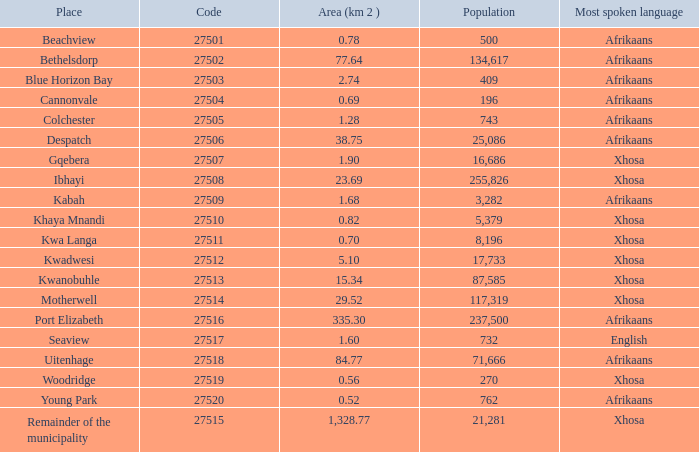I'm looking to parse the entire table for insights. Could you assist me with that? {'header': ['Place', 'Code', 'Area (km 2 )', 'Population', 'Most spoken language'], 'rows': [['Beachview', '27501', '0.78', '500', 'Afrikaans'], ['Bethelsdorp', '27502', '77.64', '134,617', 'Afrikaans'], ['Blue Horizon Bay', '27503', '2.74', '409', 'Afrikaans'], ['Cannonvale', '27504', '0.69', '196', 'Afrikaans'], ['Colchester', '27505', '1.28', '743', 'Afrikaans'], ['Despatch', '27506', '38.75', '25,086', 'Afrikaans'], ['Gqebera', '27507', '1.90', '16,686', 'Xhosa'], ['Ibhayi', '27508', '23.69', '255,826', 'Xhosa'], ['Kabah', '27509', '1.68', '3,282', 'Afrikaans'], ['Khaya Mnandi', '27510', '0.82', '5,379', 'Xhosa'], ['Kwa Langa', '27511', '0.70', '8,196', 'Xhosa'], ['Kwadwesi', '27512', '5.10', '17,733', 'Xhosa'], ['Kwanobuhle', '27513', '15.34', '87,585', 'Xhosa'], ['Motherwell', '27514', '29.52', '117,319', 'Xhosa'], ['Port Elizabeth', '27516', '335.30', '237,500', 'Afrikaans'], ['Seaview', '27517', '1.60', '732', 'English'], ['Uitenhage', '27518', '84.77', '71,666', 'Afrikaans'], ['Woodridge', '27519', '0.56', '270', 'Xhosa'], ['Young Park', '27520', '0.52', '762', 'Afrikaans'], ['Remainder of the municipality', '27515', '1,328.77', '21,281', 'Xhosa']]} What is the lowest code number for the remainder of the municipality that has an area bigger than 15.34 squared kilometers, a population greater than 762 and a language of xhosa spoken? 27515.0. 